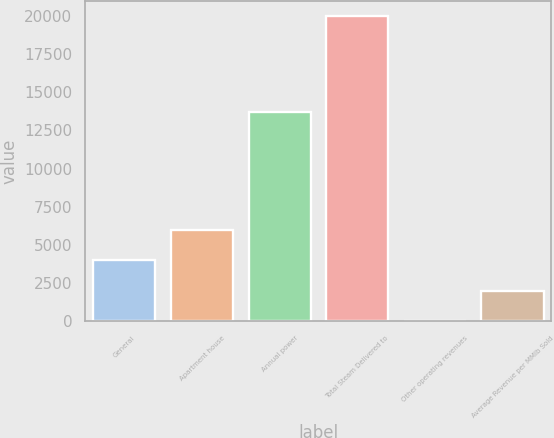<chart> <loc_0><loc_0><loc_500><loc_500><bar_chart><fcel>General<fcel>Apartment house<fcel>Annual power<fcel>Total Steam Delivered to<fcel>Other operating revenues<fcel>Average Revenue per MMlb Sold<nl><fcel>3997.4<fcel>5995.1<fcel>13722<fcel>19979<fcel>2<fcel>1999.7<nl></chart> 